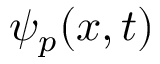Convert formula to latex. <formula><loc_0><loc_0><loc_500><loc_500>\psi _ { p } ( x , t )</formula> 